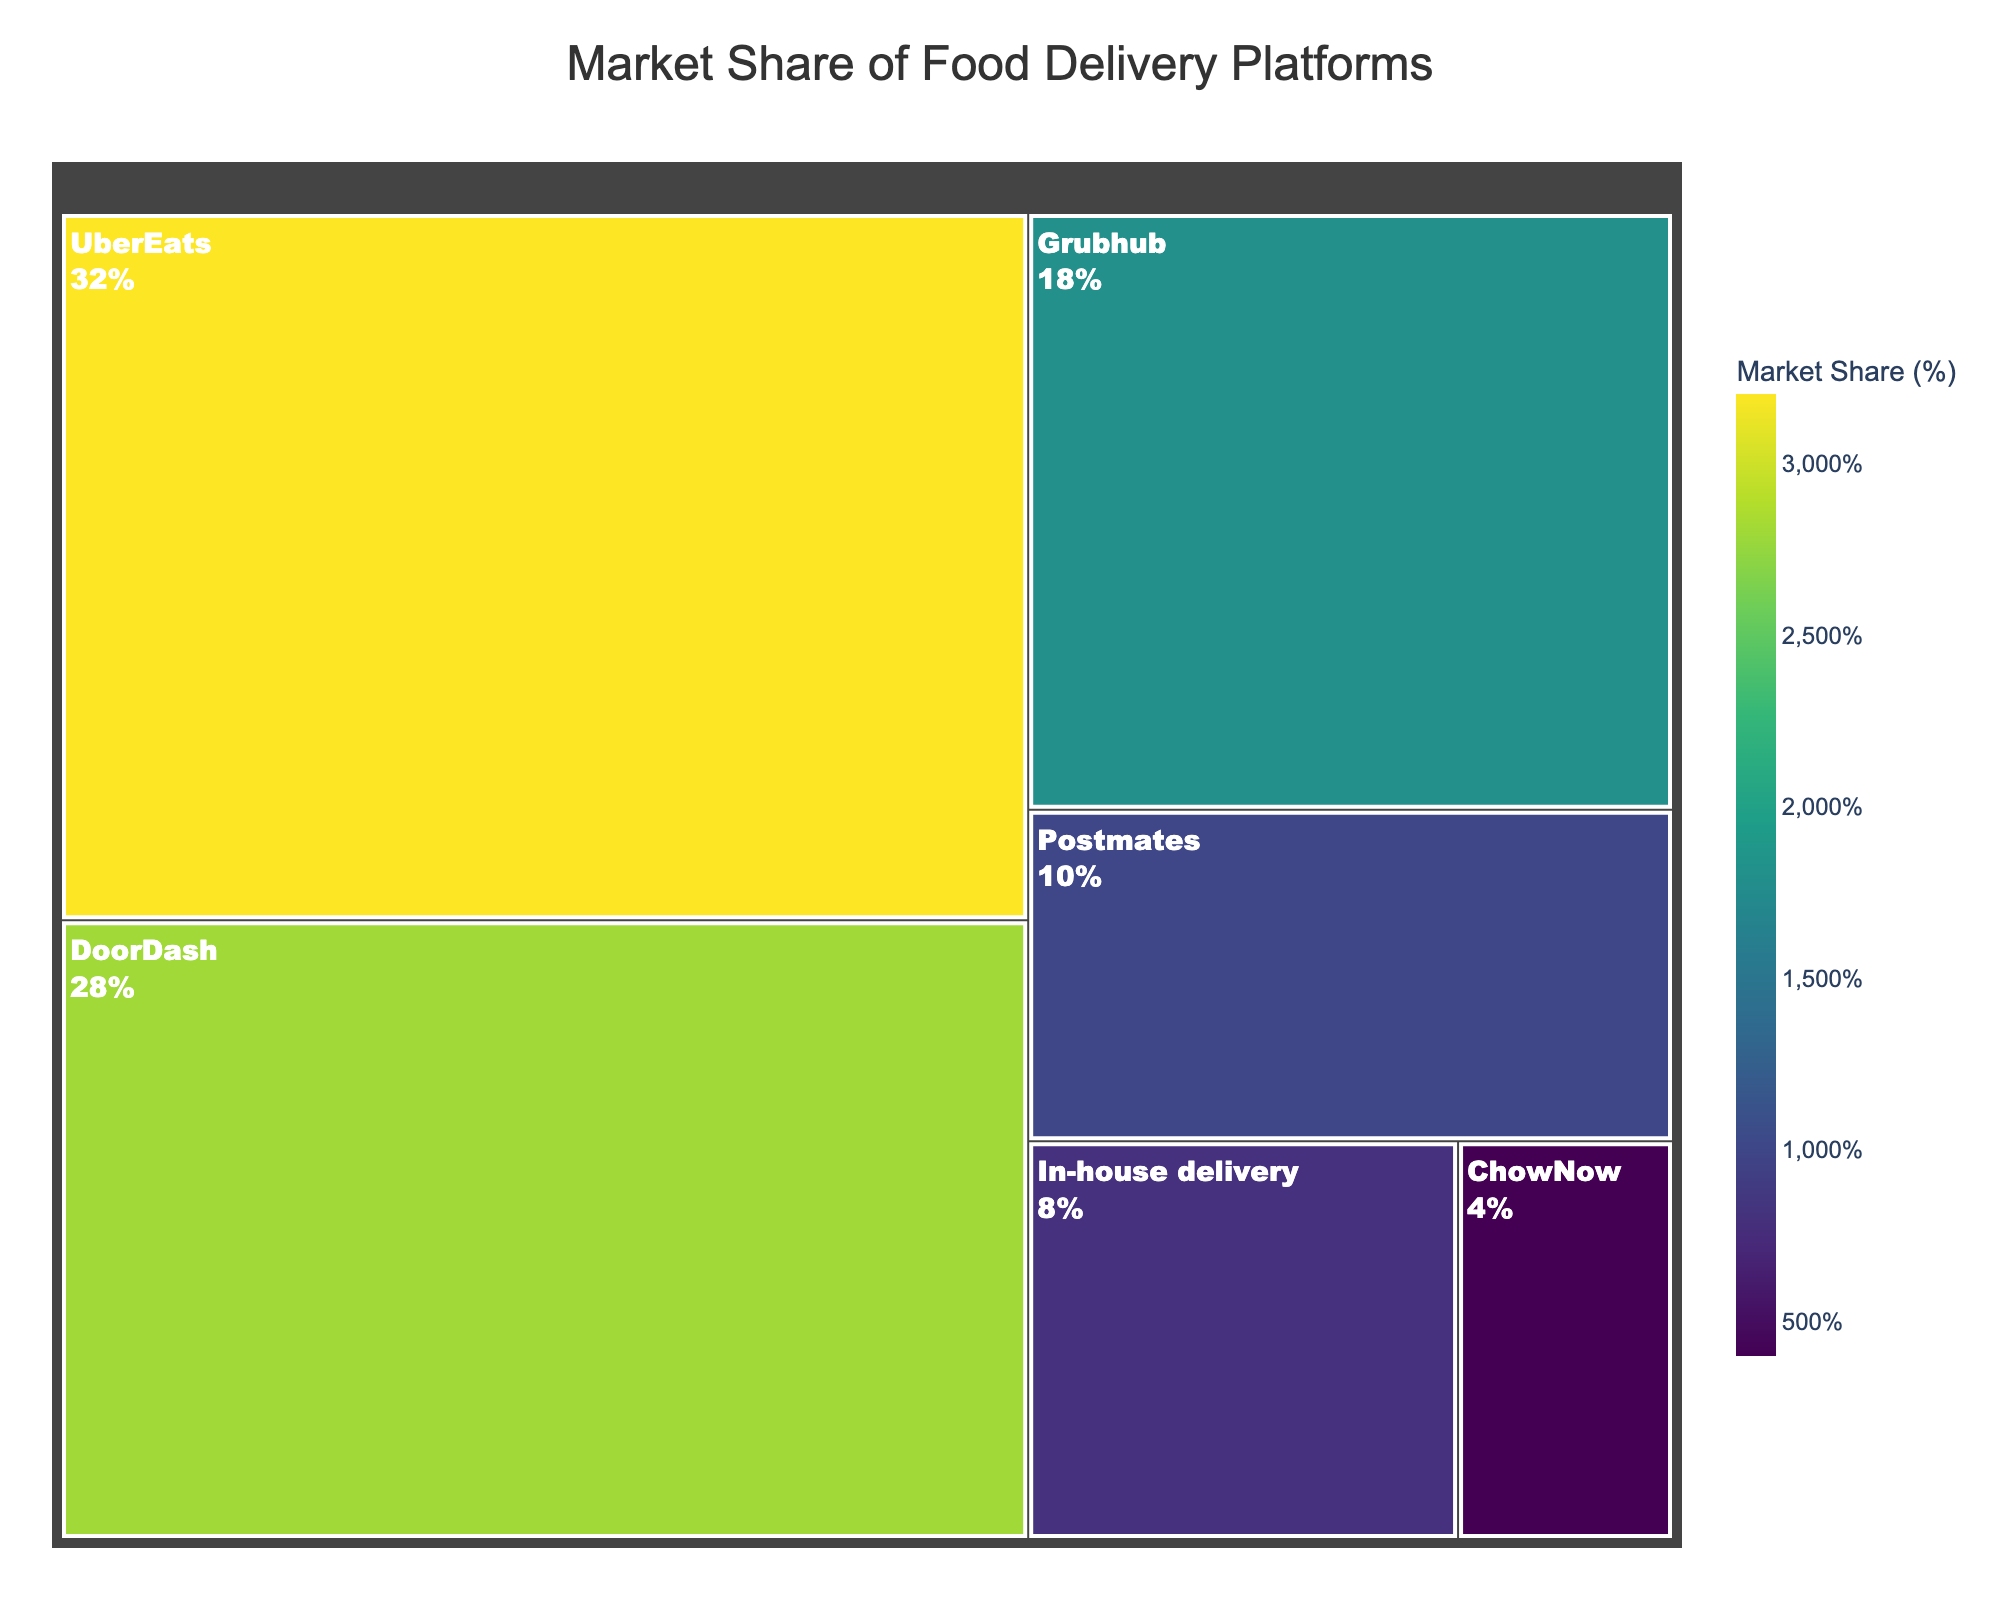What's the largest market share represented in the treemap? The largest market share can be found by identifying the biggest block in the treemap. In this case, UberEats appears to have the largest share.
Answer: 32% What's the combined market share of DoorDash and Grubhub? To find the combined market share, add the percentages of DoorDash (28%) and Grubhub (18%). 28 + 18 = 46
Answer: 46% How much larger is UberEats' market share compared to Postmates'? To determine the difference, subtract Postmates' market share (10%) from UberEats' market share (32%). 32 - 10 = 22
Answer: 22% Which platform has the smallest market share, and what is it? The smallest market share can be identified by finding the smallest block in the treemap, which is ChowNow.
Answer: 4% What's the percentage difference between the market share of In-house delivery and UberEats? Subtract In-house delivery’s market share (8%) from UberEats’ market share (32%). 32 - 8 = 24
Answer: 24% If Postmates increased its market share by 5%, what would its new market share be? Add 5% to Postmates' current market share (10%). 10 + 5 = 15
Answer: 15% Which platforms together constitute more than half of the market share? To find this, add the shares of the largest platforms until the sum exceeds 50%. UberEats (32%) and DoorDash (28%) together make 60%.
Answer: UberEats and DoorDash What's the average market share of all platforms represented in the treemap? To find the average, sum all the market shares and divide by the number of platforms. (32 + 28 + 18 + 10 + 8 + 4) / 6 = 16.67
Answer: 16.67% Which food delivery platforms have less than 20% market share? Identify platforms with a market share less than 20%. These are Grubhub (18%), Postmates (10%), In-house delivery (8%), and ChowNow (4%).
Answer: Grubhub, Postmates, In-house delivery, ChowNow 